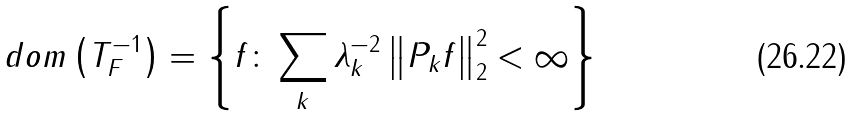<formula> <loc_0><loc_0><loc_500><loc_500>d o m \left ( T _ { F } ^ { - 1 } \right ) = \left \{ f \colon \sum _ { k } \lambda _ { k } ^ { - 2 } \left \| P _ { k } f \right \| _ { 2 } ^ { 2 } < \infty \right \}</formula> 